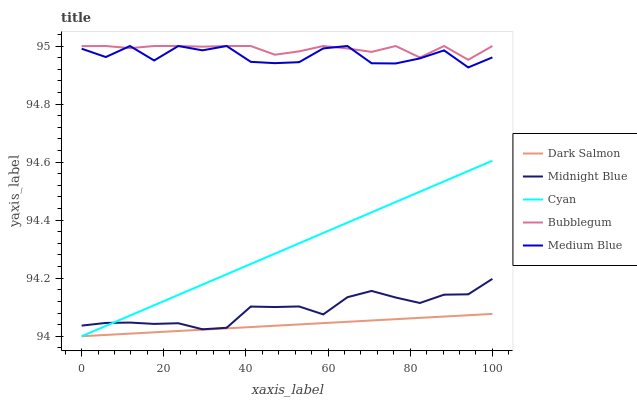Does Dark Salmon have the minimum area under the curve?
Answer yes or no. Yes. Does Bubblegum have the maximum area under the curve?
Answer yes or no. Yes. Does Medium Blue have the minimum area under the curve?
Answer yes or no. No. Does Medium Blue have the maximum area under the curve?
Answer yes or no. No. Is Dark Salmon the smoothest?
Answer yes or no. Yes. Is Medium Blue the roughest?
Answer yes or no. Yes. Is Medium Blue the smoothest?
Answer yes or no. No. Is Dark Salmon the roughest?
Answer yes or no. No. Does Cyan have the lowest value?
Answer yes or no. Yes. Does Medium Blue have the lowest value?
Answer yes or no. No. Does Bubblegum have the highest value?
Answer yes or no. Yes. Does Dark Salmon have the highest value?
Answer yes or no. No. Is Cyan less than Bubblegum?
Answer yes or no. Yes. Is Medium Blue greater than Dark Salmon?
Answer yes or no. Yes. Does Dark Salmon intersect Cyan?
Answer yes or no. Yes. Is Dark Salmon less than Cyan?
Answer yes or no. No. Is Dark Salmon greater than Cyan?
Answer yes or no. No. Does Cyan intersect Bubblegum?
Answer yes or no. No. 